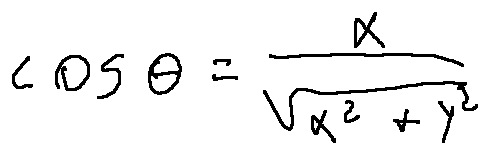Convert formula to latex. <formula><loc_0><loc_0><loc_500><loc_500>\cos \theta = \frac { x } { \sqrt { x ^ { 2 } + y ^ { 2 } } }</formula> 